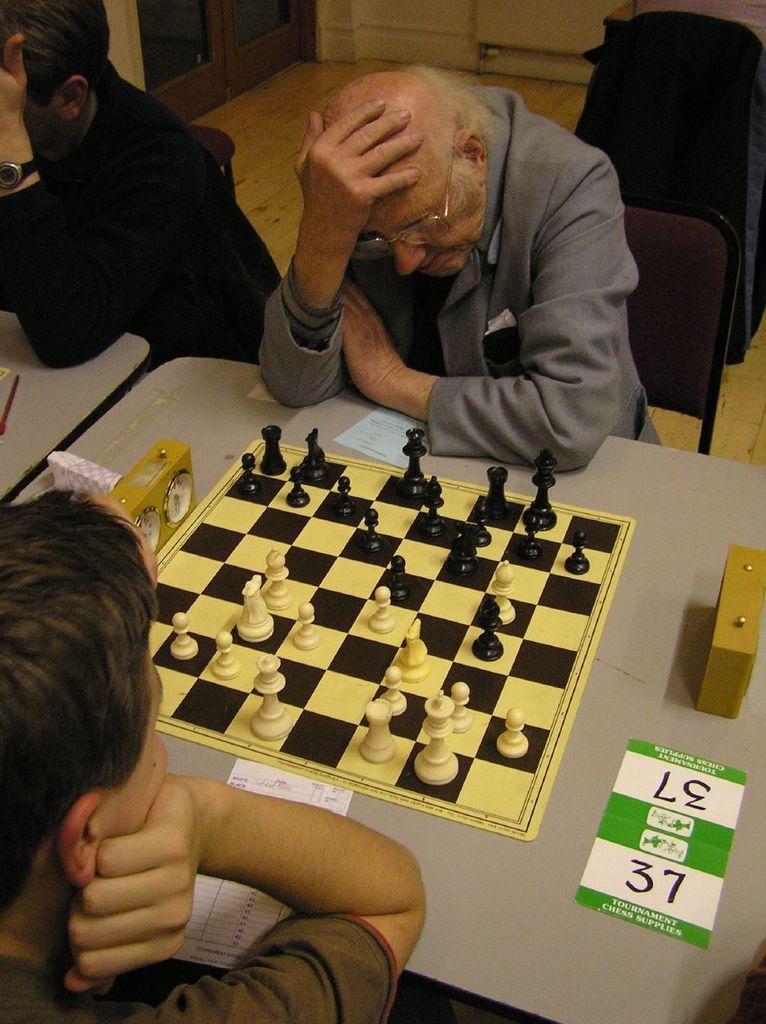Please provide a concise description of this image. In this image i can see two men sitting on a chair and playing chess on a table, at the back ground i can see a wooden wall. 